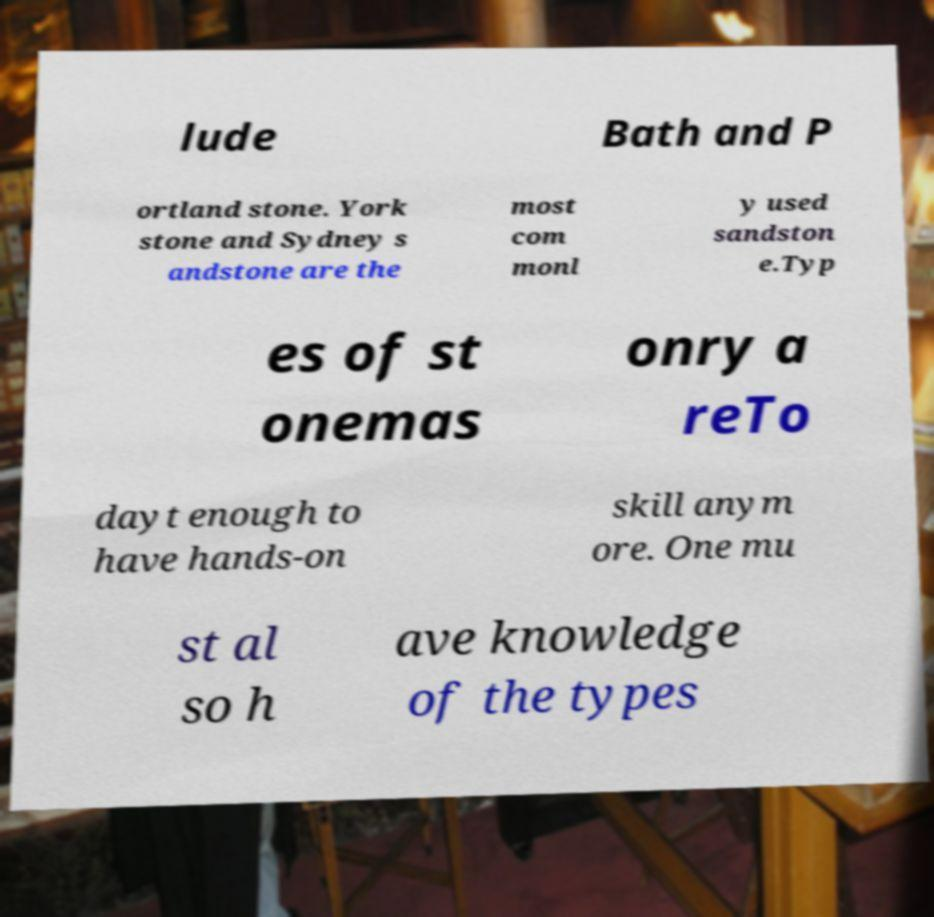Could you assist in decoding the text presented in this image and type it out clearly? lude Bath and P ortland stone. York stone and Sydney s andstone are the most com monl y used sandston e.Typ es of st onemas onry a reTo dayt enough to have hands-on skill anym ore. One mu st al so h ave knowledge of the types 